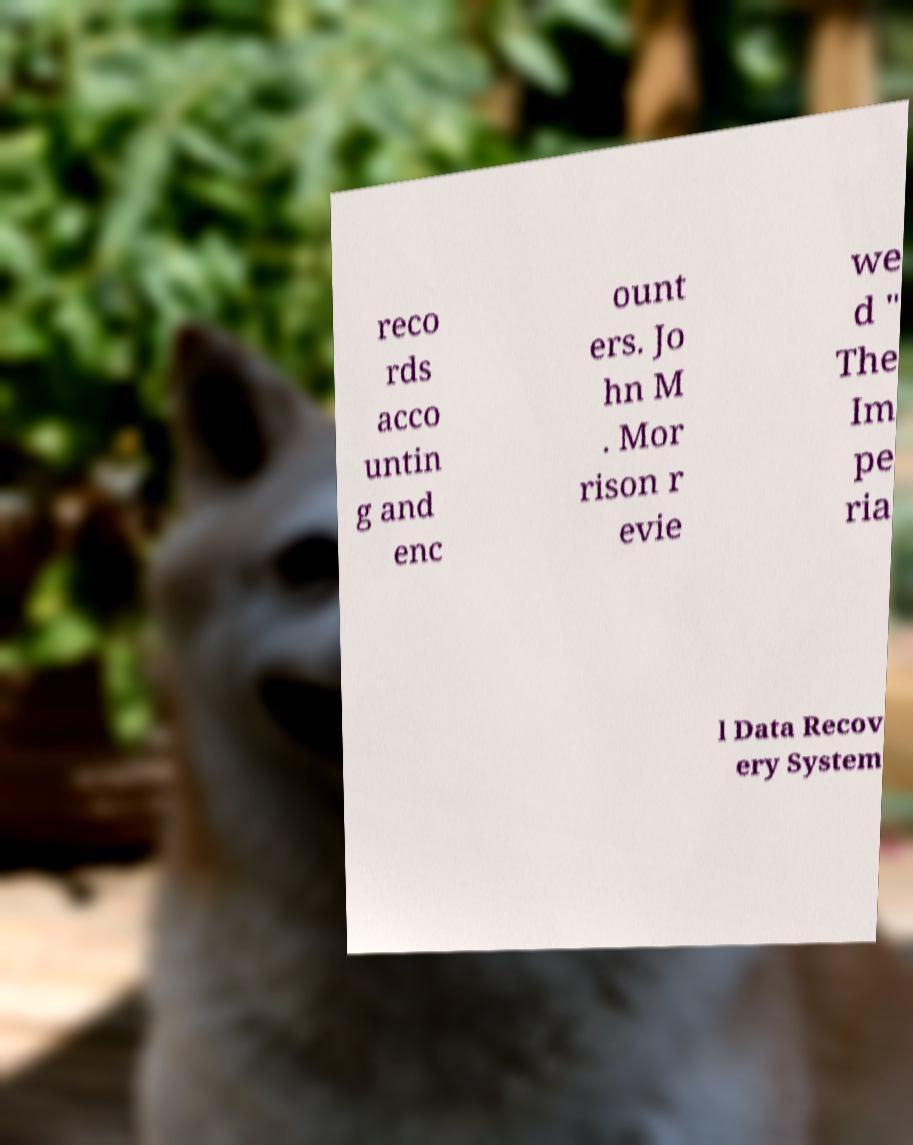Please identify and transcribe the text found in this image. reco rds acco untin g and enc ount ers. Jo hn M . Mor rison r evie we d " The Im pe ria l Data Recov ery System 